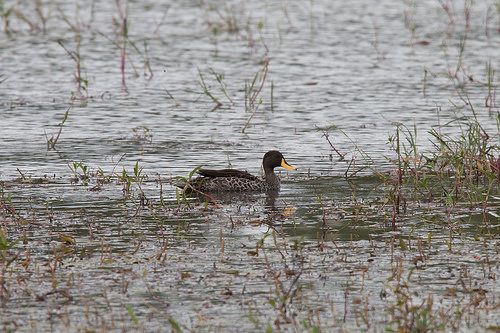<image>
Can you confirm if the duck is in front of the grass? No. The duck is not in front of the grass. The spatial positioning shows a different relationship between these objects. 